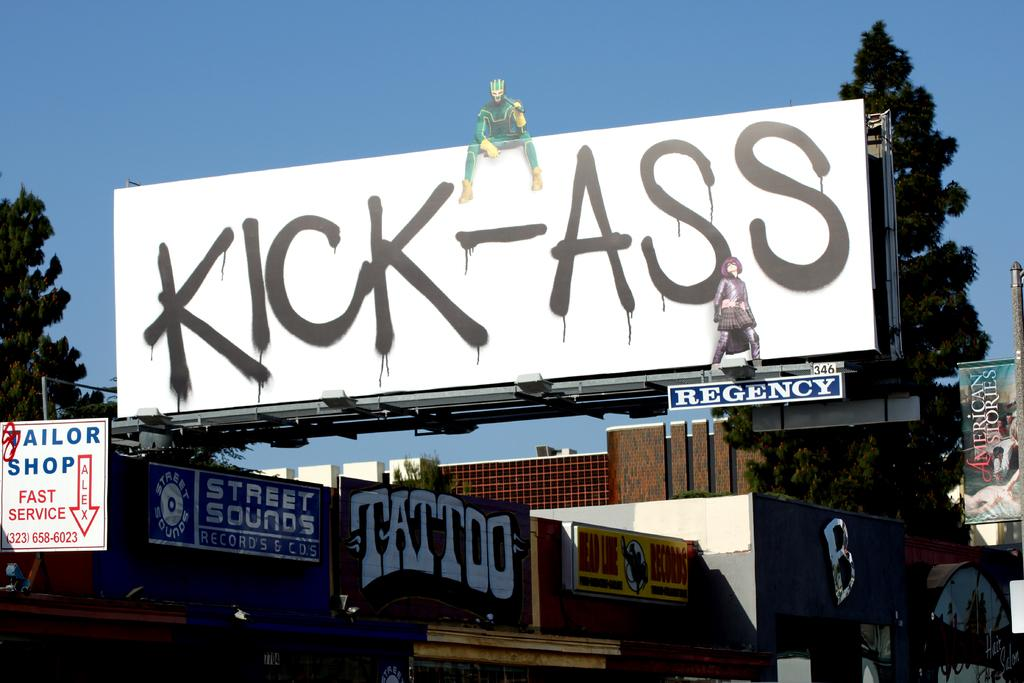<image>
Describe the image concisely. Large white billboard with black letters that say "Kick-Ass". 